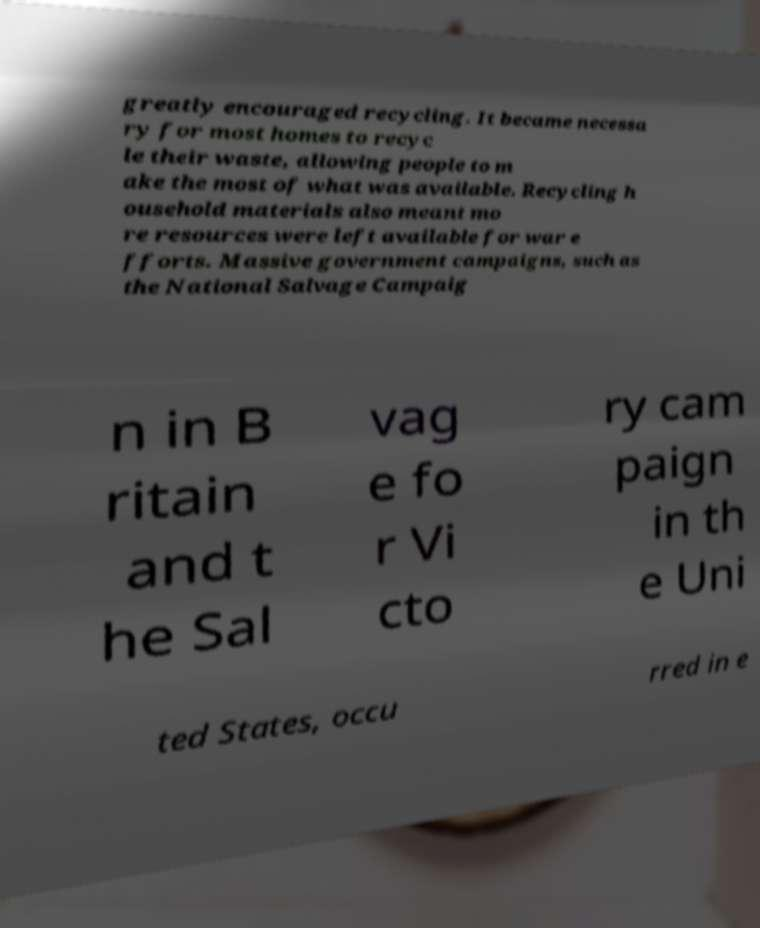Could you extract and type out the text from this image? greatly encouraged recycling. It became necessa ry for most homes to recyc le their waste, allowing people to m ake the most of what was available. Recycling h ousehold materials also meant mo re resources were left available for war e fforts. Massive government campaigns, such as the National Salvage Campaig n in B ritain and t he Sal vag e fo r Vi cto ry cam paign in th e Uni ted States, occu rred in e 